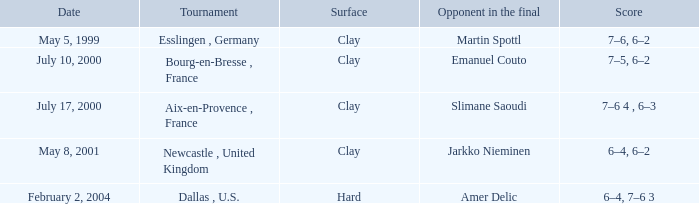What is the Score of the Tournament with Opponent in the final of Martin Spottl? 7–6, 6–2. 